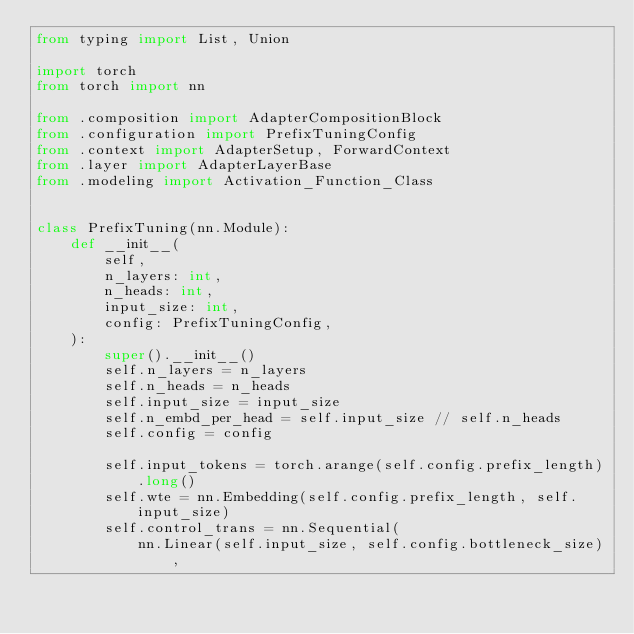<code> <loc_0><loc_0><loc_500><loc_500><_Python_>from typing import List, Union

import torch
from torch import nn

from .composition import AdapterCompositionBlock
from .configuration import PrefixTuningConfig
from .context import AdapterSetup, ForwardContext
from .layer import AdapterLayerBase
from .modeling import Activation_Function_Class


class PrefixTuning(nn.Module):
    def __init__(
        self,
        n_layers: int,
        n_heads: int,
        input_size: int,
        config: PrefixTuningConfig,
    ):
        super().__init__()
        self.n_layers = n_layers
        self.n_heads = n_heads
        self.input_size = input_size
        self.n_embd_per_head = self.input_size // self.n_heads
        self.config = config

        self.input_tokens = torch.arange(self.config.prefix_length).long()
        self.wte = nn.Embedding(self.config.prefix_length, self.input_size)
        self.control_trans = nn.Sequential(
            nn.Linear(self.input_size, self.config.bottleneck_size),</code> 